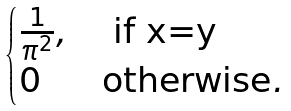Convert formula to latex. <formula><loc_0><loc_0><loc_500><loc_500>\begin{cases} \frac { 1 } { \pi ^ { 2 } } , & \text { if x=y} \\ 0 & \text {otherwise} . \end{cases}</formula> 